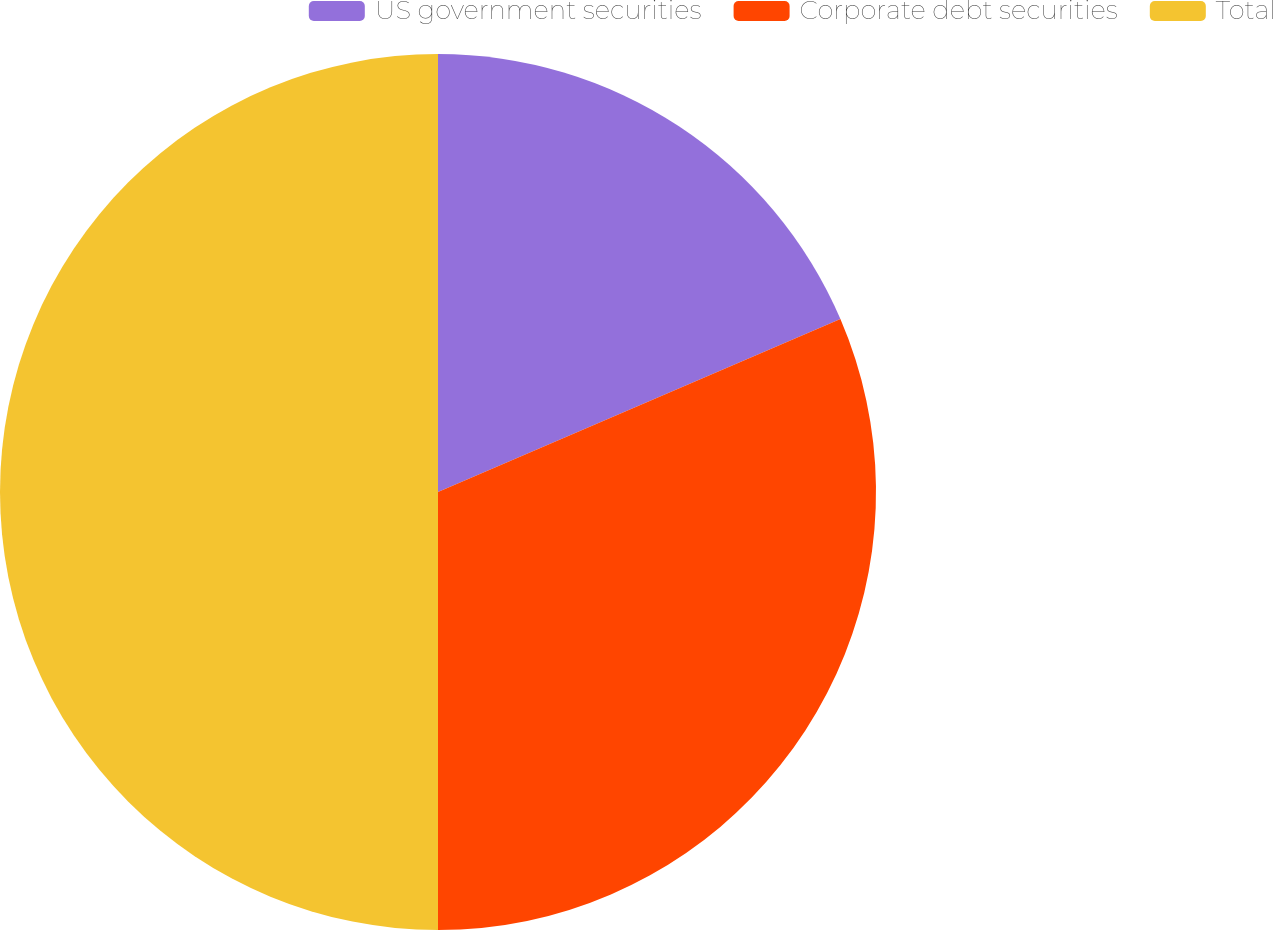Convert chart to OTSL. <chart><loc_0><loc_0><loc_500><loc_500><pie_chart><fcel>US government securities<fcel>Corporate debt securities<fcel>Total<nl><fcel>18.54%<fcel>31.46%<fcel>50.0%<nl></chart> 